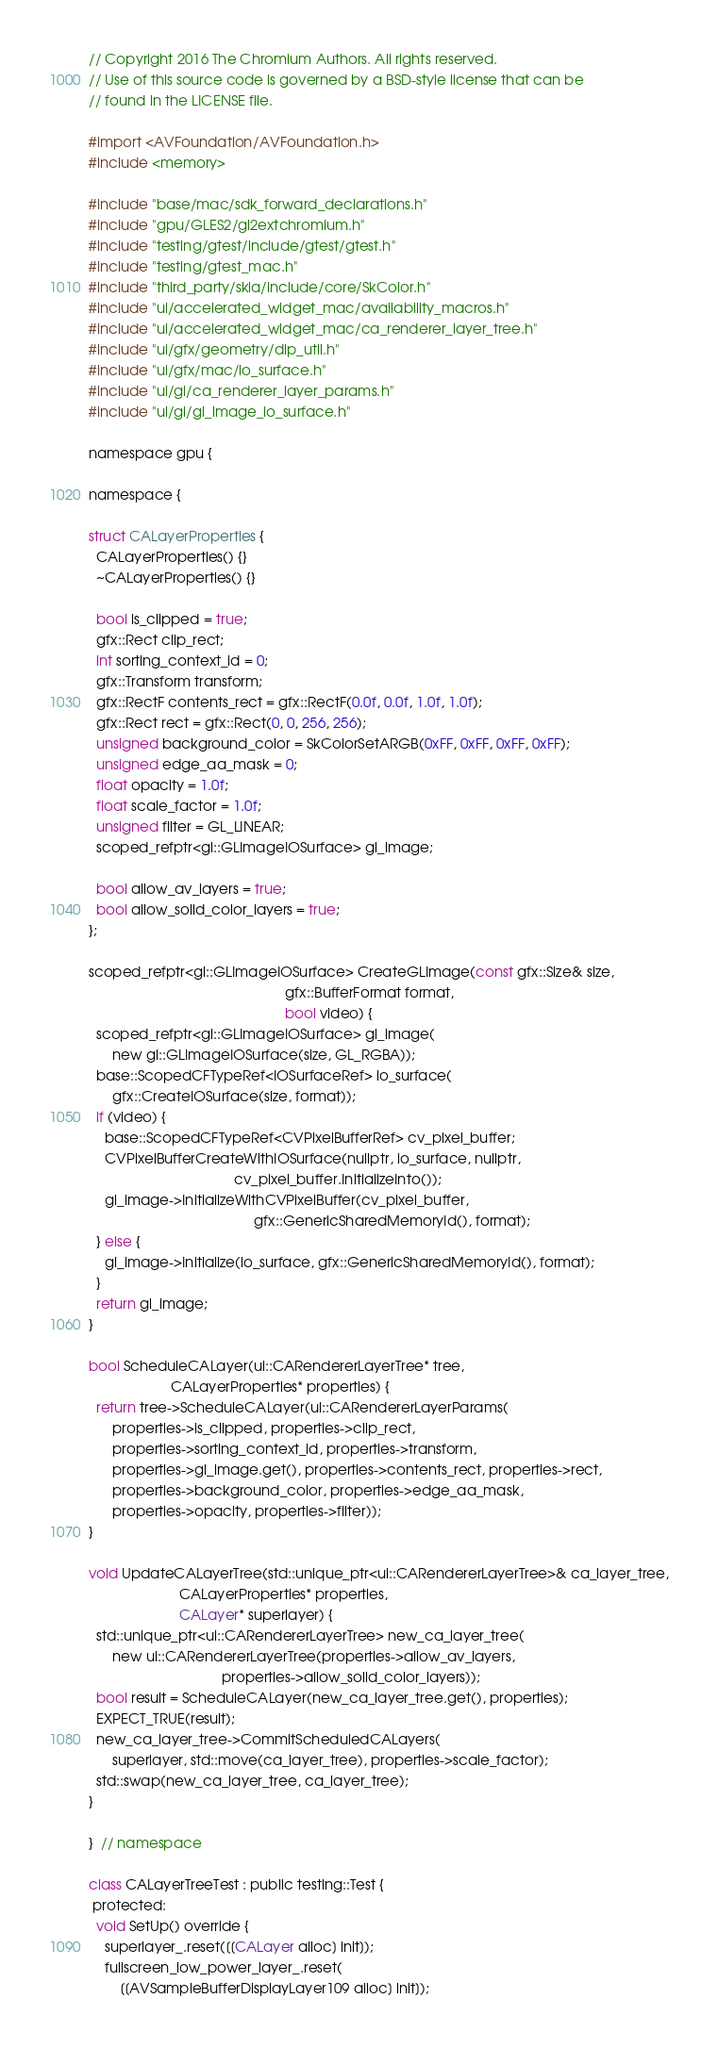<code> <loc_0><loc_0><loc_500><loc_500><_ObjectiveC_>// Copyright 2016 The Chromium Authors. All rights reserved.
// Use of this source code is governed by a BSD-style license that can be
// found in the LICENSE file.

#import <AVFoundation/AVFoundation.h>
#include <memory>

#include "base/mac/sdk_forward_declarations.h"
#include "gpu/GLES2/gl2extchromium.h"
#include "testing/gtest/include/gtest/gtest.h"
#include "testing/gtest_mac.h"
#include "third_party/skia/include/core/SkColor.h"
#include "ui/accelerated_widget_mac/availability_macros.h"
#include "ui/accelerated_widget_mac/ca_renderer_layer_tree.h"
#include "ui/gfx/geometry/dip_util.h"
#include "ui/gfx/mac/io_surface.h"
#include "ui/gl/ca_renderer_layer_params.h"
#include "ui/gl/gl_image_io_surface.h"

namespace gpu {

namespace {

struct CALayerProperties {
  CALayerProperties() {}
  ~CALayerProperties() {}

  bool is_clipped = true;
  gfx::Rect clip_rect;
  int sorting_context_id = 0;
  gfx::Transform transform;
  gfx::RectF contents_rect = gfx::RectF(0.0f, 0.0f, 1.0f, 1.0f);
  gfx::Rect rect = gfx::Rect(0, 0, 256, 256);
  unsigned background_color = SkColorSetARGB(0xFF, 0xFF, 0xFF, 0xFF);
  unsigned edge_aa_mask = 0;
  float opacity = 1.0f;
  float scale_factor = 1.0f;
  unsigned filter = GL_LINEAR;
  scoped_refptr<gl::GLImageIOSurface> gl_image;

  bool allow_av_layers = true;
  bool allow_solid_color_layers = true;
};

scoped_refptr<gl::GLImageIOSurface> CreateGLImage(const gfx::Size& size,
                                                  gfx::BufferFormat format,
                                                  bool video) {
  scoped_refptr<gl::GLImageIOSurface> gl_image(
      new gl::GLImageIOSurface(size, GL_RGBA));
  base::ScopedCFTypeRef<IOSurfaceRef> io_surface(
      gfx::CreateIOSurface(size, format));
  if (video) {
    base::ScopedCFTypeRef<CVPixelBufferRef> cv_pixel_buffer;
    CVPixelBufferCreateWithIOSurface(nullptr, io_surface, nullptr,
                                     cv_pixel_buffer.InitializeInto());
    gl_image->InitializeWithCVPixelBuffer(cv_pixel_buffer,
                                          gfx::GenericSharedMemoryId(), format);
  } else {
    gl_image->Initialize(io_surface, gfx::GenericSharedMemoryId(), format);
  }
  return gl_image;
}

bool ScheduleCALayer(ui::CARendererLayerTree* tree,
                     CALayerProperties* properties) {
  return tree->ScheduleCALayer(ui::CARendererLayerParams(
      properties->is_clipped, properties->clip_rect,
      properties->sorting_context_id, properties->transform,
      properties->gl_image.get(), properties->contents_rect, properties->rect,
      properties->background_color, properties->edge_aa_mask,
      properties->opacity, properties->filter));
}

void UpdateCALayerTree(std::unique_ptr<ui::CARendererLayerTree>& ca_layer_tree,
                       CALayerProperties* properties,
                       CALayer* superlayer) {
  std::unique_ptr<ui::CARendererLayerTree> new_ca_layer_tree(
      new ui::CARendererLayerTree(properties->allow_av_layers,
                                  properties->allow_solid_color_layers));
  bool result = ScheduleCALayer(new_ca_layer_tree.get(), properties);
  EXPECT_TRUE(result);
  new_ca_layer_tree->CommitScheduledCALayers(
      superlayer, std::move(ca_layer_tree), properties->scale_factor);
  std::swap(new_ca_layer_tree, ca_layer_tree);
}

}  // namespace

class CALayerTreeTest : public testing::Test {
 protected:
  void SetUp() override {
    superlayer_.reset([[CALayer alloc] init]);
    fullscreen_low_power_layer_.reset(
        [[AVSampleBufferDisplayLayer109 alloc] init]);</code> 